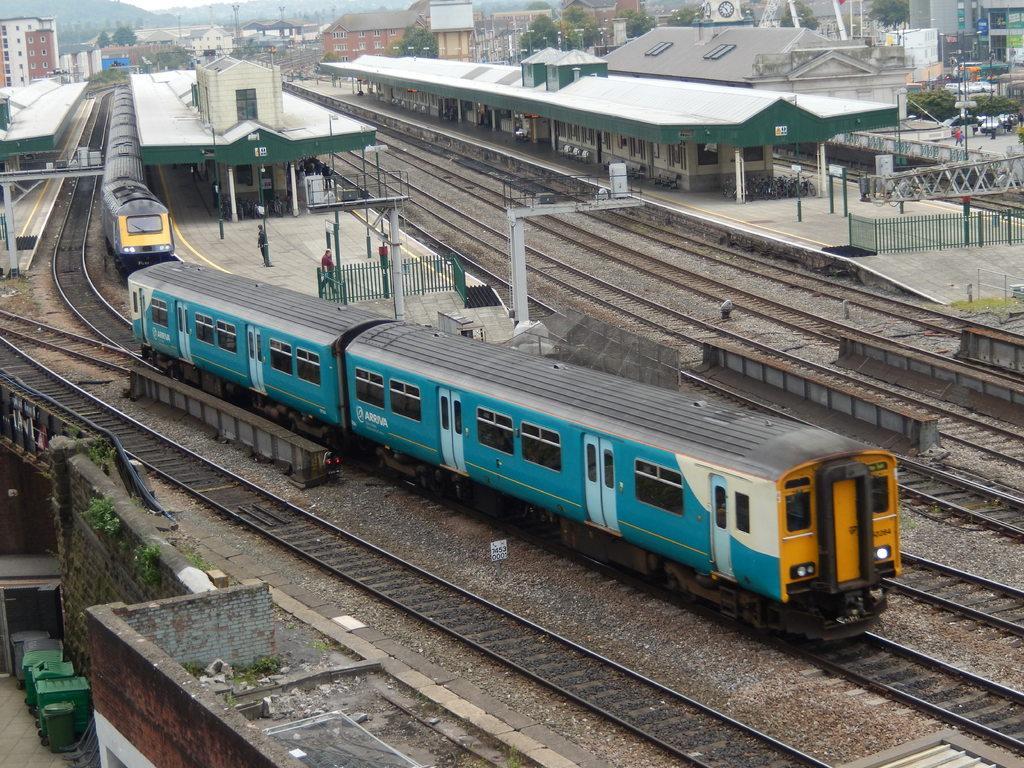Could you give a brief overview of what you see in this image? In this picture we can see trains on railway tracks, platforms with some people standing and bicycles on it, buildings, trees, banners, fences, walls, bins, poles, clock and some objects and in the background we can see mountains. 